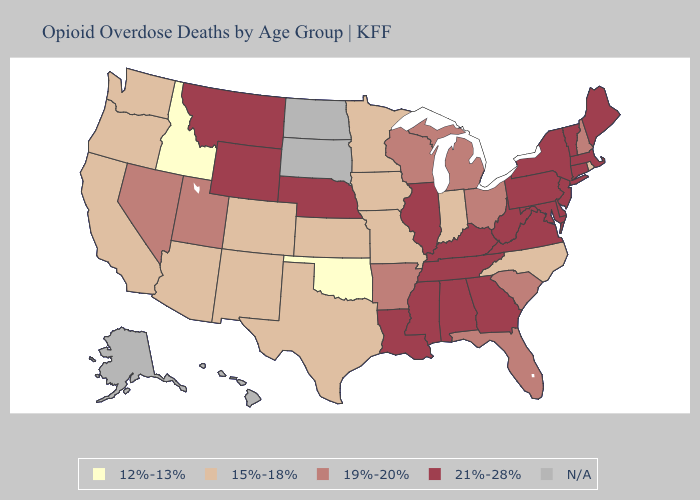What is the highest value in the South ?
Keep it brief. 21%-28%. Does Kansas have the highest value in the MidWest?
Concise answer only. No. What is the lowest value in the MidWest?
Answer briefly. 15%-18%. Which states hav the highest value in the West?
Short answer required. Montana, Wyoming. Name the states that have a value in the range 19%-20%?
Be succinct. Arkansas, Florida, Michigan, Nevada, New Hampshire, Ohio, South Carolina, Utah, Wisconsin. What is the value of Arizona?
Quick response, please. 15%-18%. Does the map have missing data?
Quick response, please. Yes. Does Virginia have the highest value in the USA?
Be succinct. Yes. What is the value of New Jersey?
Short answer required. 21%-28%. Name the states that have a value in the range N/A?
Answer briefly. Alaska, Hawaii, North Dakota, South Dakota. Name the states that have a value in the range 21%-28%?
Short answer required. Alabama, Connecticut, Delaware, Georgia, Illinois, Kentucky, Louisiana, Maine, Maryland, Massachusetts, Mississippi, Montana, Nebraska, New Jersey, New York, Pennsylvania, Tennessee, Vermont, Virginia, West Virginia, Wyoming. Name the states that have a value in the range 12%-13%?
Be succinct. Idaho, Oklahoma. 